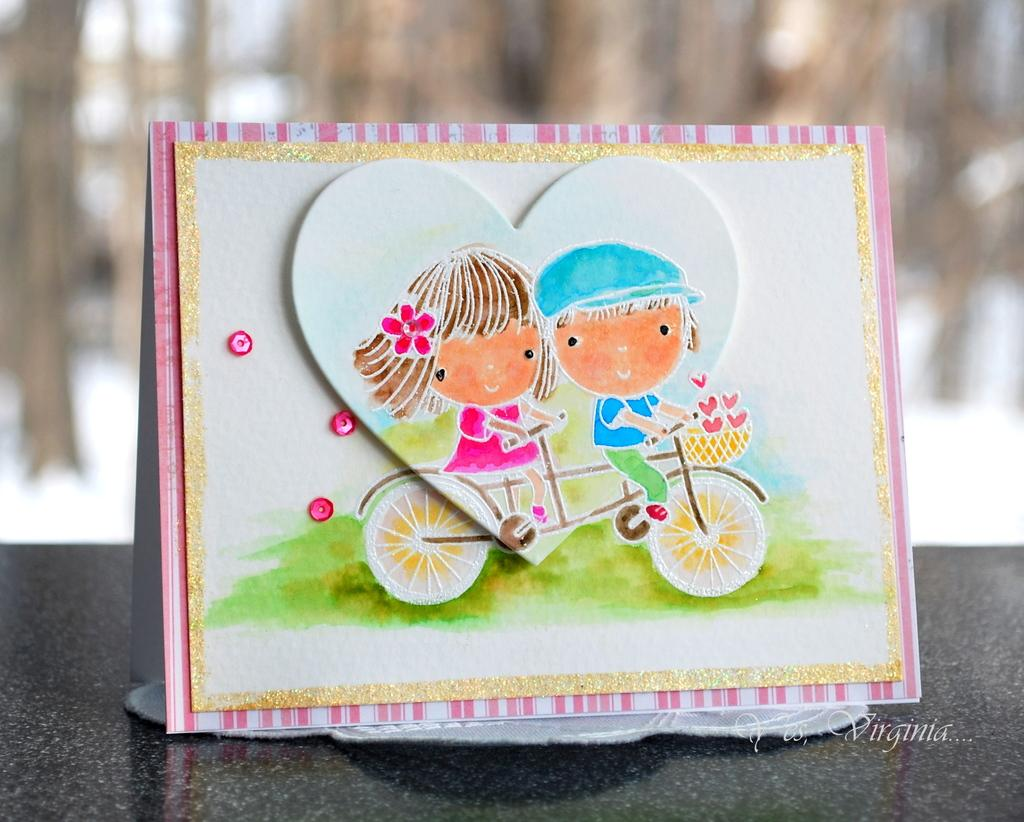What is the main object in the image? There is a card in the image. What is depicted on the card? There is a painting on the card. Is there any text present in the image? Yes, there is text at the bottom of the image. How would you describe the background of the image? The background of the image is blurred. What type of vest can be seen in the image? There is no vest present in the image. 